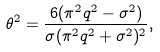<formula> <loc_0><loc_0><loc_500><loc_500>\theta ^ { 2 } = \frac { 6 ( \pi ^ { 2 } q ^ { 2 } - \sigma ^ { 2 } ) } { \sigma ( \pi ^ { 2 } q ^ { 2 } + \sigma ^ { 2 } ) ^ { 2 } } ,</formula> 